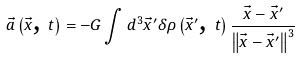<formula> <loc_0><loc_0><loc_500><loc_500>\vec { a } \left ( \vec { x } \text {, } t \right ) = - G \int d ^ { 3 } \vec { x } ^ { \prime } \delta \rho \left ( \vec { x } ^ { \prime } \text {, } t \right ) \frac { \vec { x } - \vec { x } ^ { \prime } } { \left \| \vec { x } - \vec { x } ^ { \prime } \right \| ^ { 3 } }</formula> 